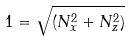<formula> <loc_0><loc_0><loc_500><loc_500>1 = \sqrt { ( N _ { x } ^ { 2 } + N _ { z } ^ { 2 } ) }</formula> 